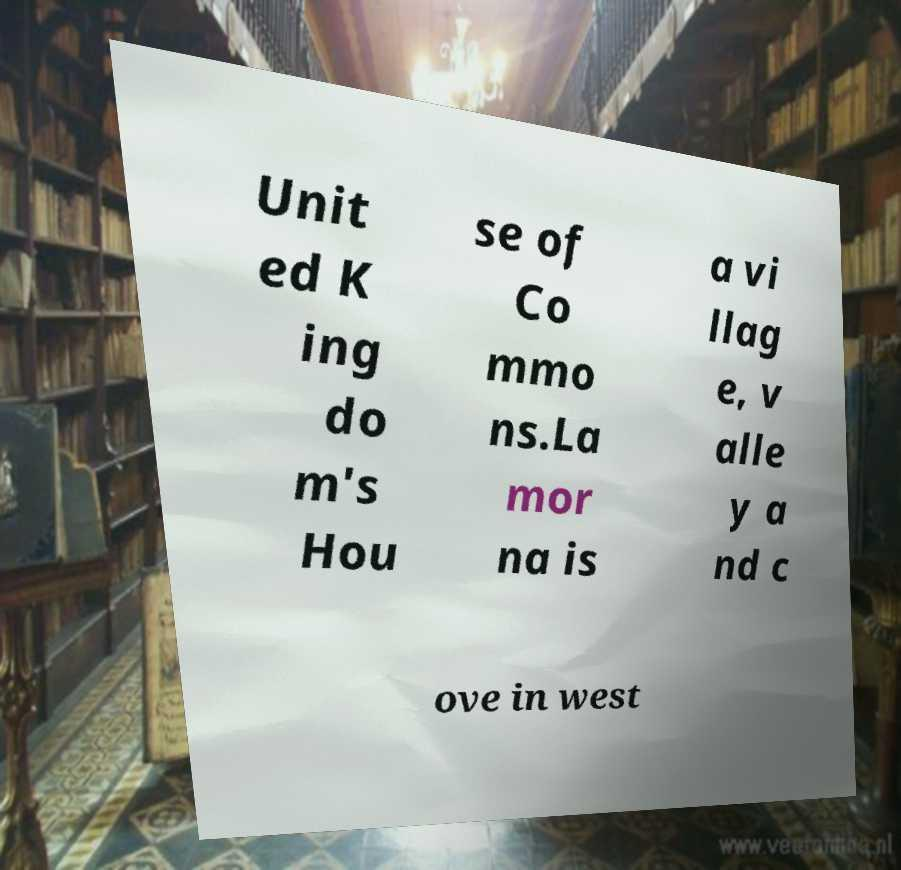Can you accurately transcribe the text from the provided image for me? Unit ed K ing do m's Hou se of Co mmo ns.La mor na is a vi llag e, v alle y a nd c ove in west 